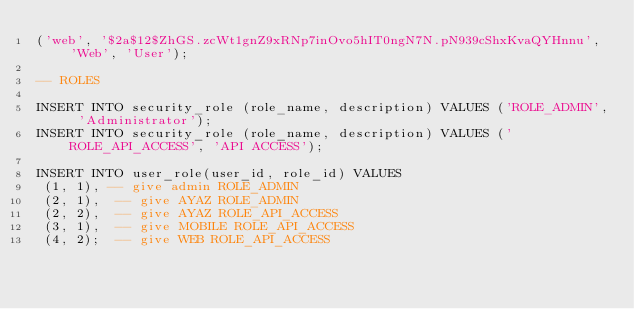Convert code to text. <code><loc_0><loc_0><loc_500><loc_500><_SQL_>('web', '$2a$12$ZhGS.zcWt1gnZ9xRNp7inOvo5hIT0ngN7N.pN939cShxKvaQYHnnu', 'Web', 'User');

-- ROLES

INSERT INTO security_role (role_name, description) VALUES ('ROLE_ADMIN', 'Administrator');
INSERT INTO security_role (role_name, description) VALUES ('ROLE_API_ACCESS', 'API ACCESS');

INSERT INTO user_role(user_id, role_id) VALUES
 (1, 1), -- give admin ROLE_ADMIN
 (2, 1),  -- give AYAZ ROLE_ADMIN
 (2, 2),  -- give AYAZ ROLE_API_ACCESS
 (3, 1),  -- give MOBILE ROLE_API_ACCESS
 (4, 2);  -- give WEB ROLE_API_ACCESS
</code> 